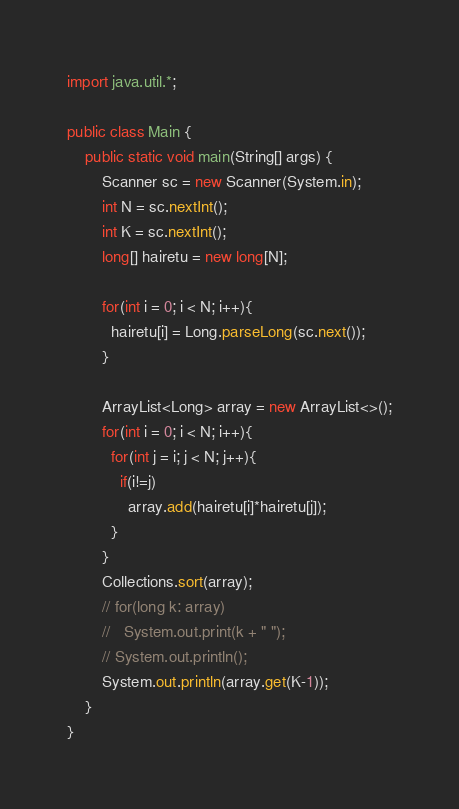Convert code to text. <code><loc_0><loc_0><loc_500><loc_500><_Java_>import java.util.*;

public class Main {
    public static void main(String[] args) {
        Scanner sc = new Scanner(System.in);
        int N = sc.nextInt();
        int K = sc.nextInt();
        long[] hairetu = new long[N];

        for(int i = 0; i < N; i++){
          hairetu[i] = Long.parseLong(sc.next());
        }

        ArrayList<Long> array = new ArrayList<>();
        for(int i = 0; i < N; i++){
          for(int j = i; j < N; j++){
            if(i!=j)
              array.add(hairetu[i]*hairetu[j]);
          }
        }
        Collections.sort(array);
        // for(long k: array)
        //   System.out.print(k + " ");
        // System.out.println();
        System.out.println(array.get(K-1));
    }
}</code> 